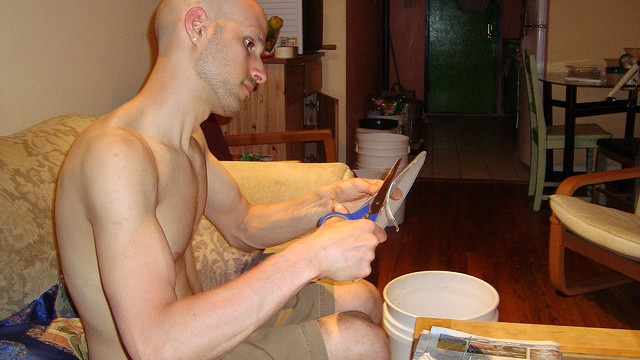Describe the objects in this image and their specific colors. I can see people in tan and gray tones, couch in tan, gray, and olive tones, chair in tan, maroon, black, and brown tones, dining table in tan, orange, and darkgray tones, and chair in tan, black, darkgreen, maroon, and gray tones in this image. 